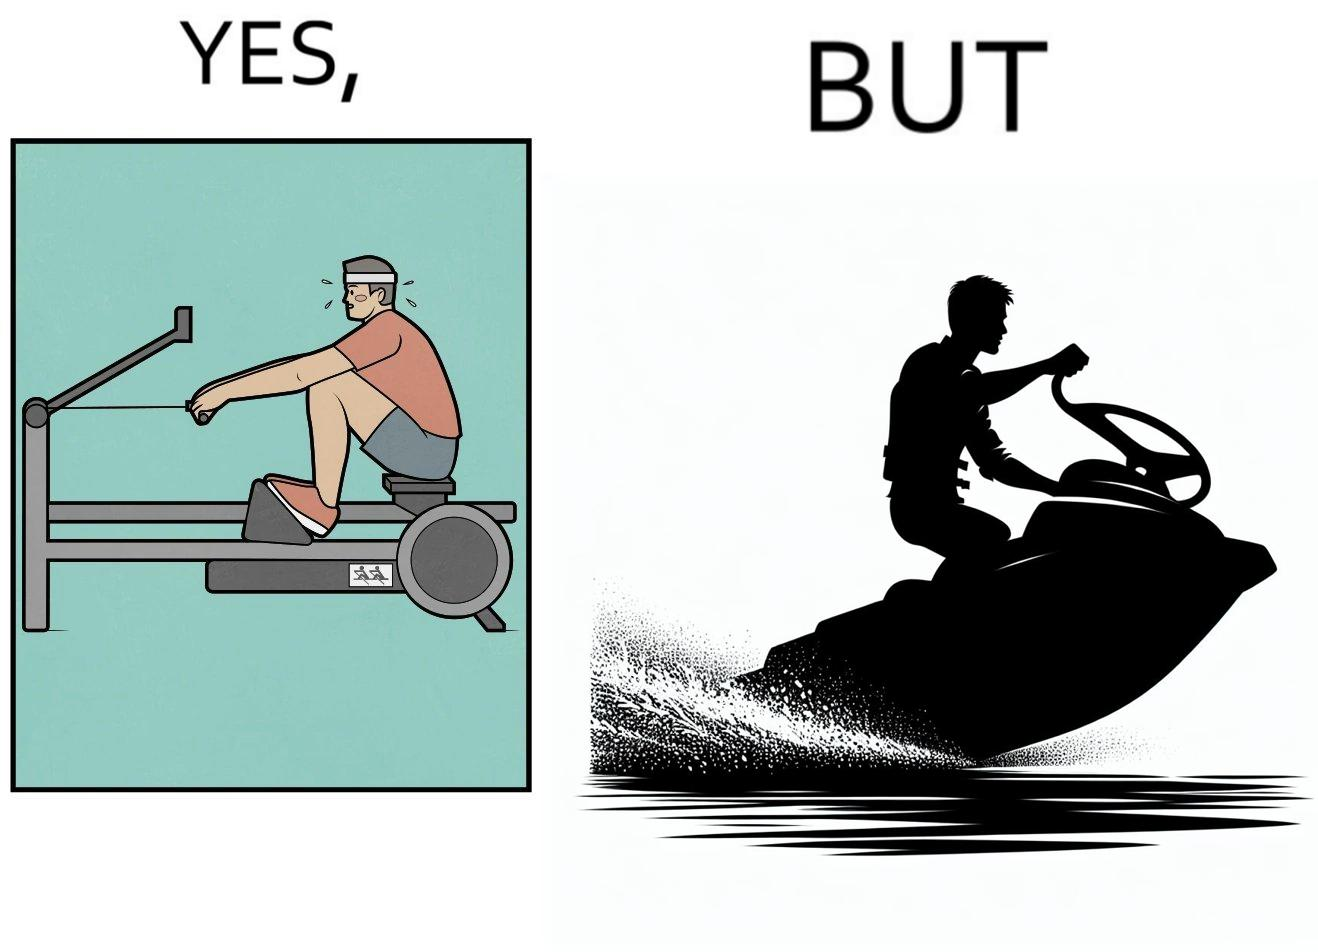Describe the satirical element in this image. The image is ironic, because people often use rowing machine at the gym don't prefer rowing when it comes to boats 